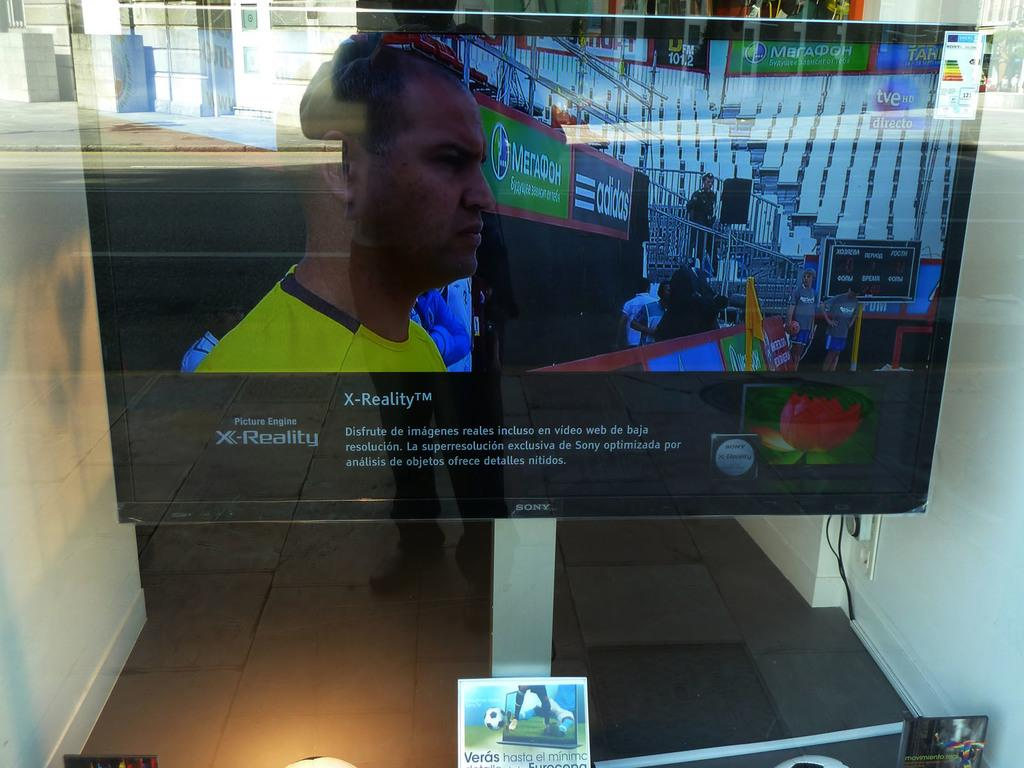<image>
Provide a brief description of the given image. Flat screen television about x reality on the screen 